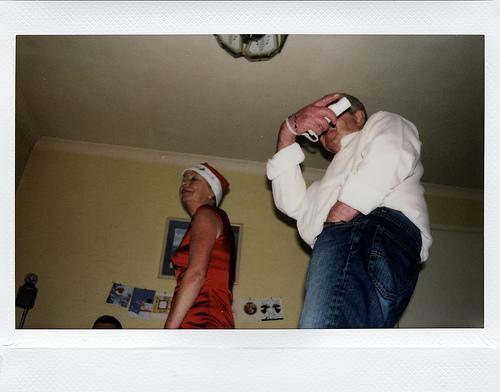How many people are there?
Give a very brief answer. 2. 